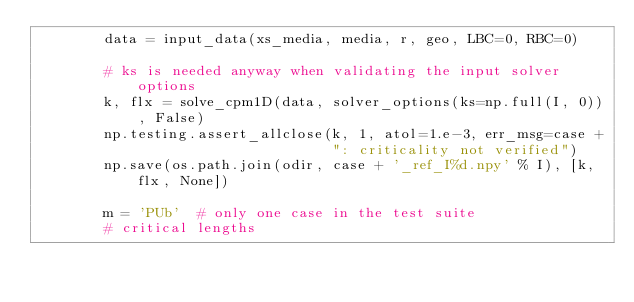<code> <loc_0><loc_0><loc_500><loc_500><_Python_>        data = input_data(xs_media, media, r, geo, LBC=0, RBC=0)
        
        # ks is needed anyway when validating the input solver options
        k, flx = solve_cpm1D(data, solver_options(ks=np.full(I, 0)), False)
        np.testing.assert_allclose(k, 1, atol=1.e-3, err_msg=case +
                                   ": criticality not verified")
        np.save(os.path.join(odir, case + '_ref_I%d.npy' % I), [k, flx, None])
        
        m = 'PUb'  # only one case in the test suite
        # critical lengths</code> 